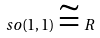Convert formula to latex. <formula><loc_0><loc_0><loc_500><loc_500>s o ( 1 , 1 ) \cong R</formula> 